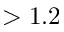<formula> <loc_0><loc_0><loc_500><loc_500>> 1 . 2</formula> 